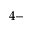<formula> <loc_0><loc_0><loc_500><loc_500>4 -</formula> 